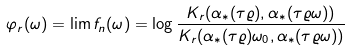<formula> <loc_0><loc_0><loc_500><loc_500>\varphi _ { r } ( \omega ) = \lim f _ { n } ( \omega ) = \log \frac { K _ { r } ( \alpha _ { * } ( \tau \varrho ) , \alpha _ { * } ( \tau \varrho \omega ) ) } { K _ { r } ( \alpha _ { * } ( \tau \varrho ) \omega _ { 0 } , \alpha _ { * } ( \tau \varrho \omega ) ) }</formula> 